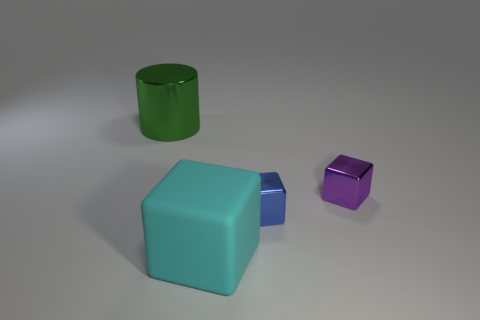What can you infer about the lighting and texture of the objects? The objects have a matte finish and are lit with diffused lighting, suggesting an indirect light source, giving them soft shadows and highlights. 